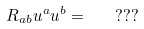Convert formula to latex. <formula><loc_0><loc_0><loc_500><loc_500>R _ { a b } u ^ { a } u ^ { b } = \quad ? ? ?</formula> 